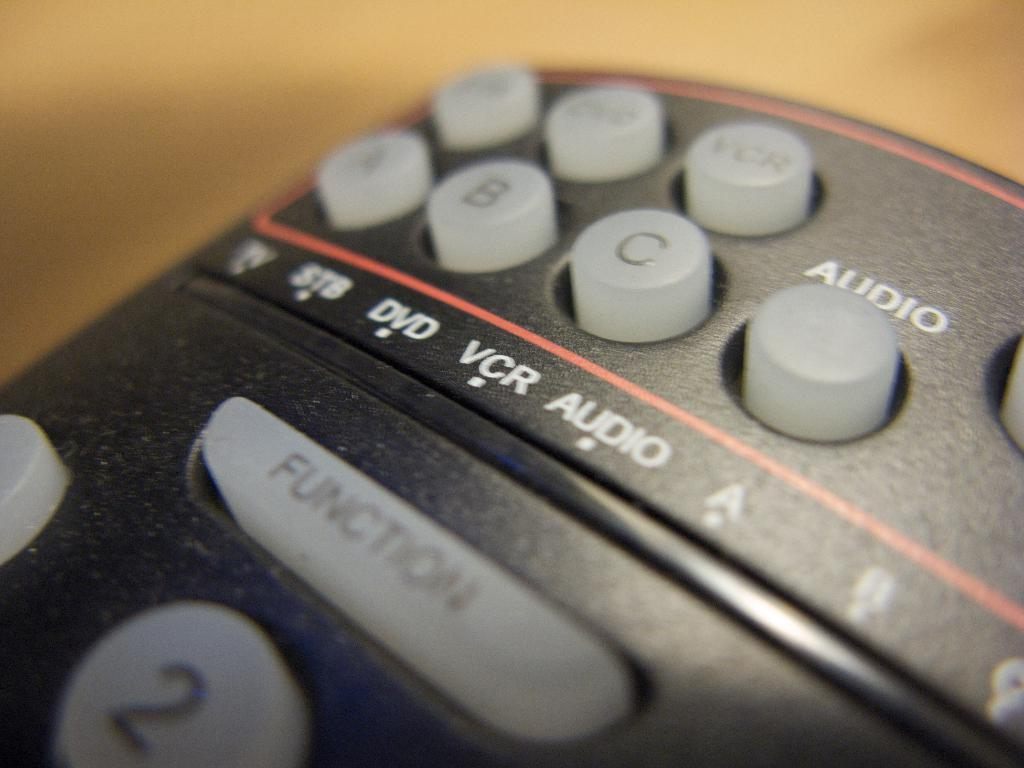<image>
Summarize the visual content of the image. A remote control that has buttons labeled a, b, and c is laying on a counter. 